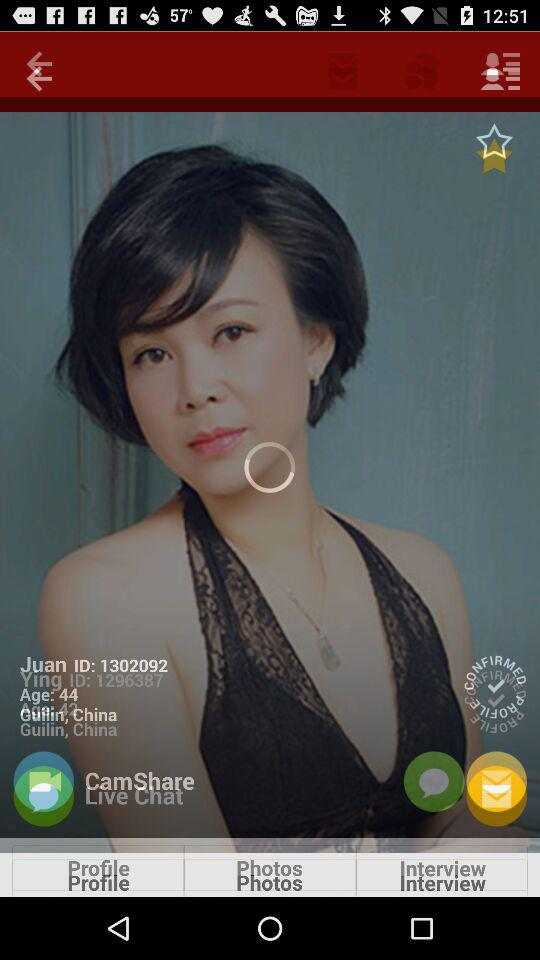What is the age of Juan? The age of Juan is 44 years. 